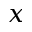<formula> <loc_0><loc_0><loc_500><loc_500>x</formula> 